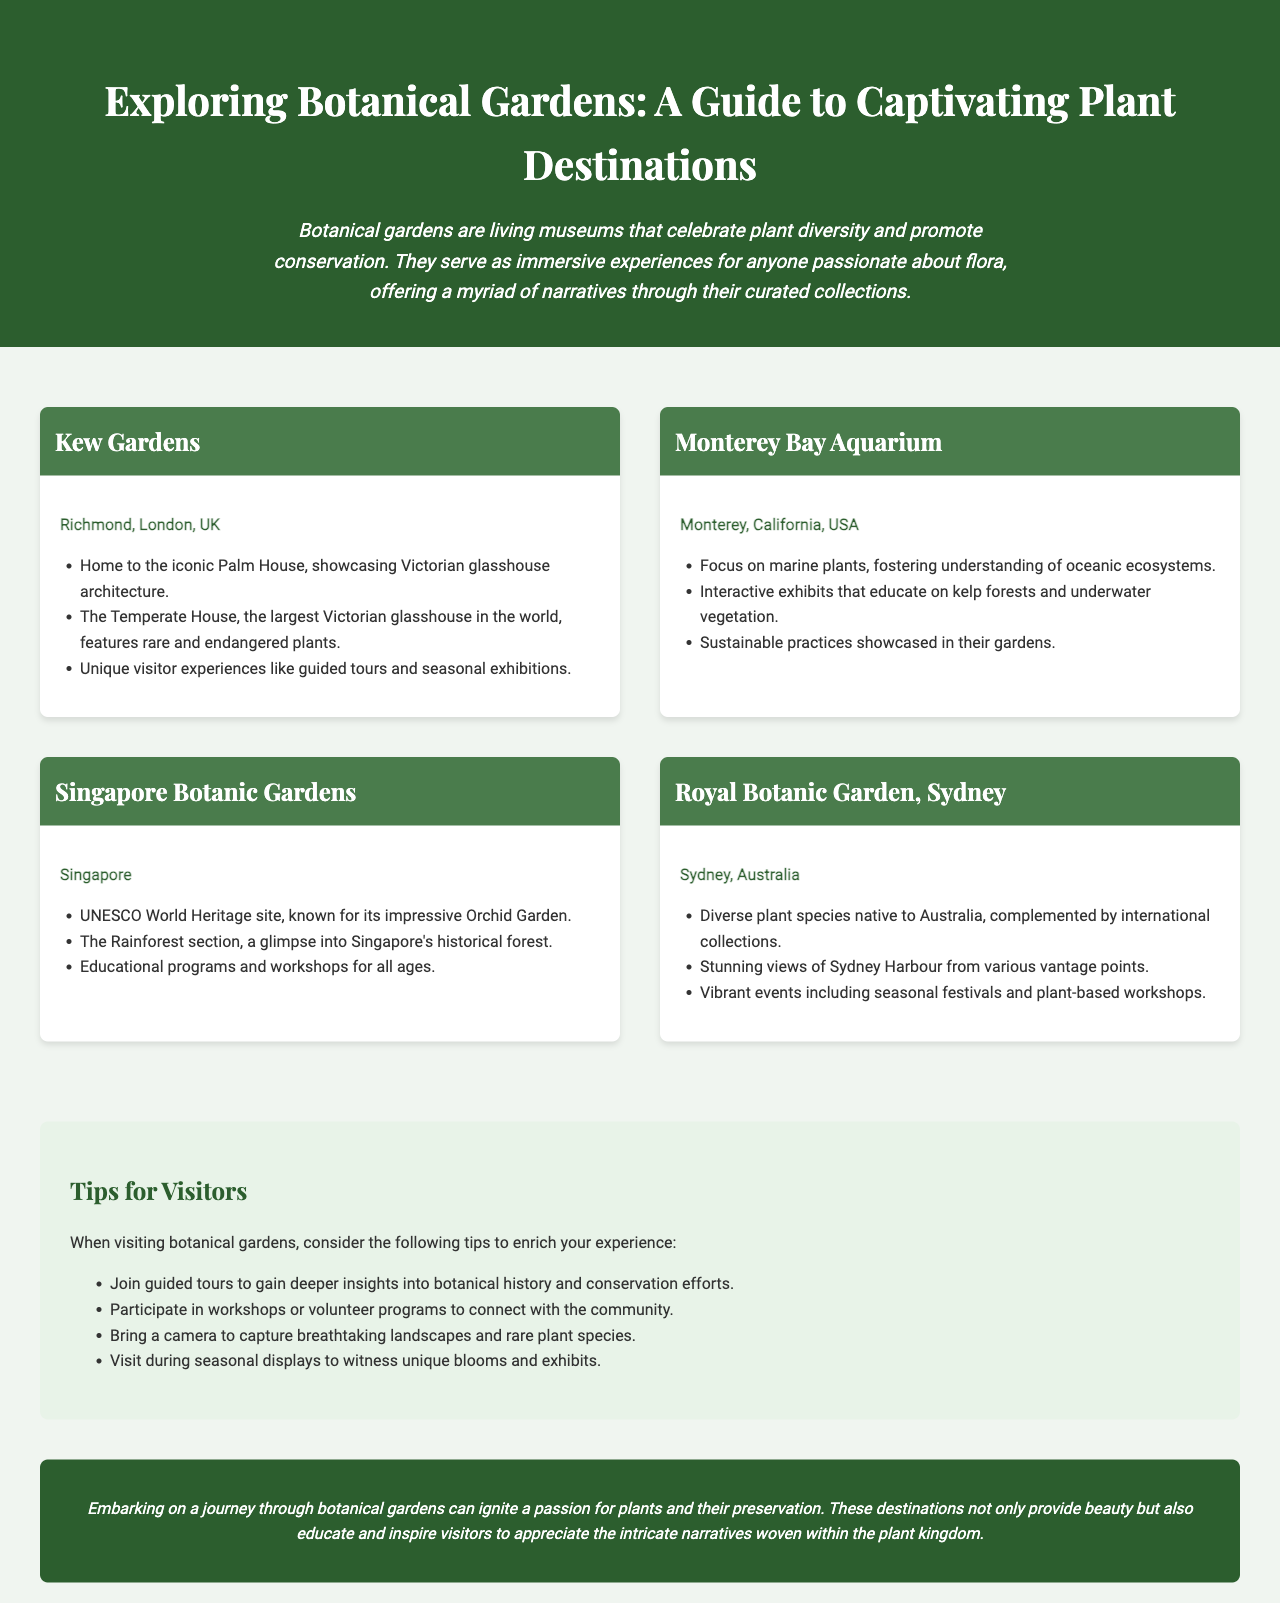What is the title of the brochure? The title of the brochure is prominently displayed at the top of the document, stating the focus on botanical gardens.
Answer: Exploring Botanical Gardens: A Guide to Captivating Plant Destinations Where is Kew Gardens located? The document provides specific locations for each botanical garden listed, including Kew Gardens, which is in Richmond, London, UK.
Answer: Richmond, London, UK What kind of plants are featured at the Singapore Botanic Gardens? The document mentions that the gardens are known for their impressive Orchid Garden and also features a Rainforest section.
Answer: Orchid Garden How many tips are provided for visitors? The document includes a list of practical advice for visitors, which enumerates several tips to enhance their experience.
Answer: Four What unique feature does the Royal Botanic Garden, Sydney offer? The document points out that this location has stunning views of Sydney Harbour visible from various vantage points.
Answer: Stunning views of Sydney Harbour What is one activity visitors can do at the Monterey Bay Aquarium? The document lists interactive exhibits that educate on specific marine plant ecosystems, indicating a hands-on approach to learning.
Answer: Interactive exhibits What designation does the Singapore Botanic Gardens hold? The document highlights the significance of the Singapore Botanic Gardens as a UNESCO World Heritage site.
Answer: UNESCO World Heritage site What should visitors bring to capture landscapes according to the tips? The tips section suggests bringing specific items to enhance the visit experience, particularly focused on photography.
Answer: Camera 